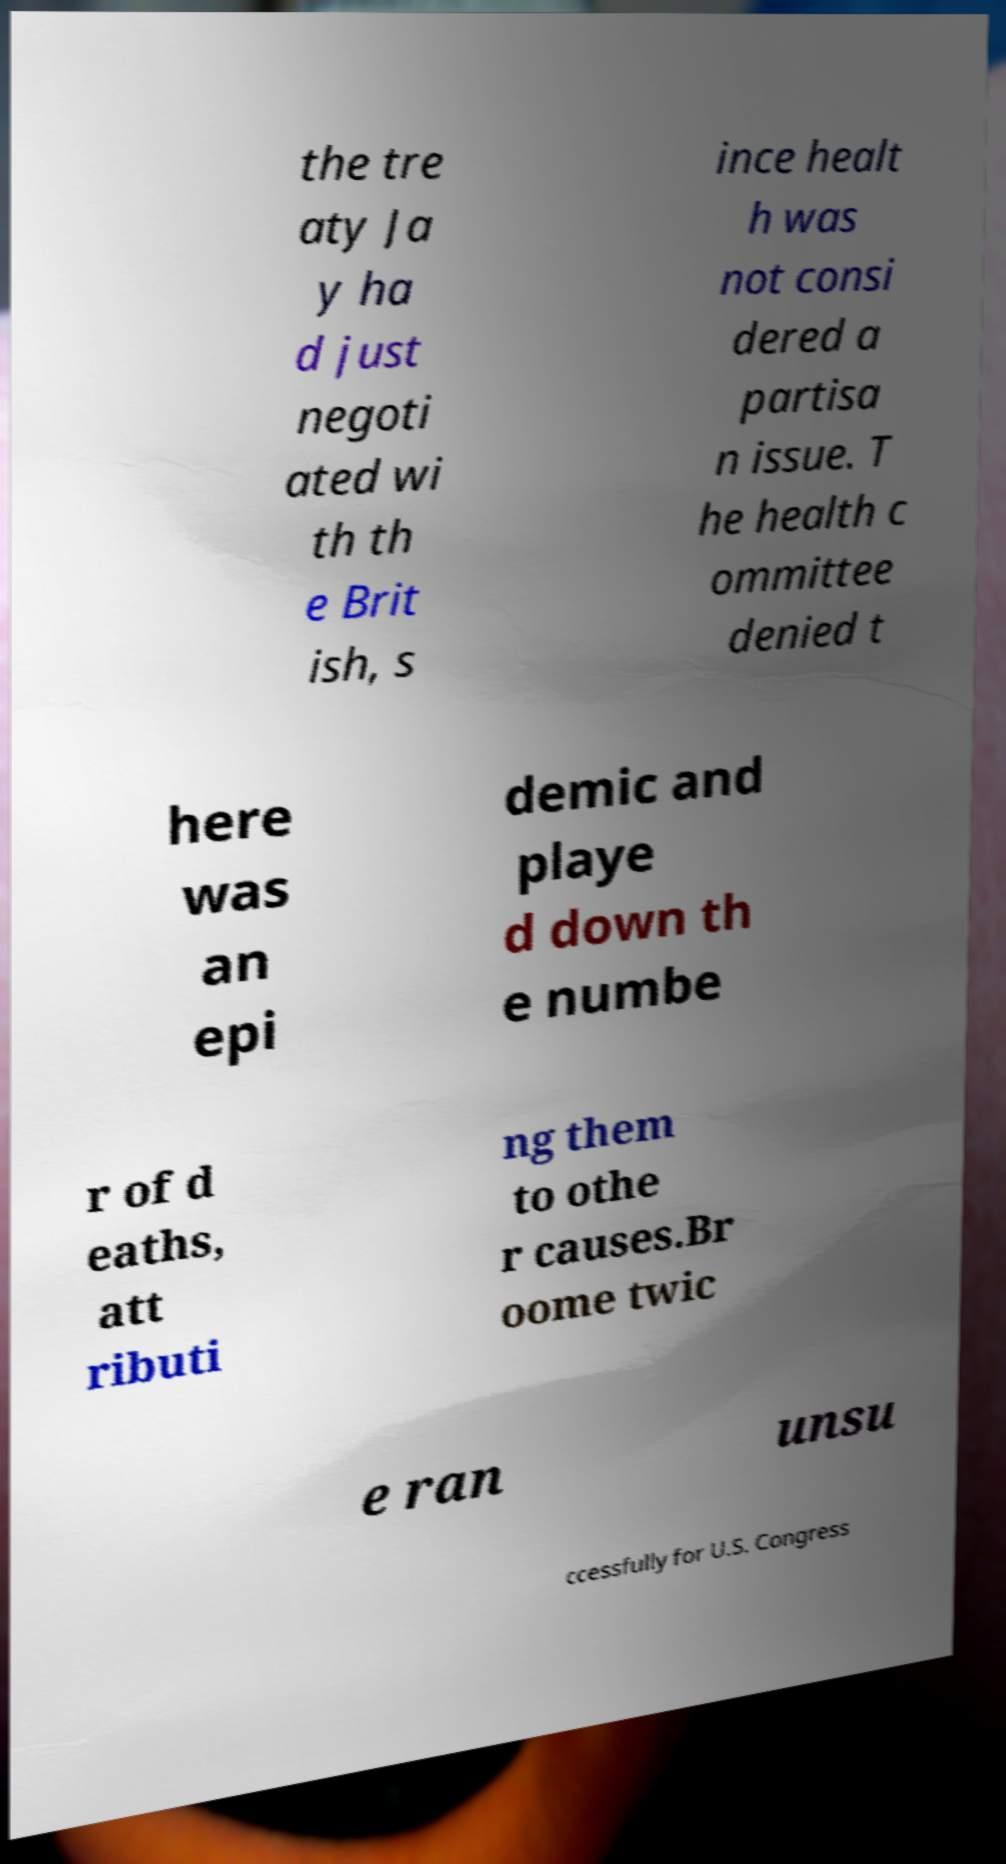For documentation purposes, I need the text within this image transcribed. Could you provide that? the tre aty Ja y ha d just negoti ated wi th th e Brit ish, s ince healt h was not consi dered a partisa n issue. T he health c ommittee denied t here was an epi demic and playe d down th e numbe r of d eaths, att ributi ng them to othe r causes.Br oome twic e ran unsu ccessfully for U.S. Congress 